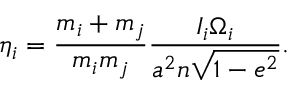Convert formula to latex. <formula><loc_0><loc_0><loc_500><loc_500>\eta _ { i } = \frac { m _ { i } + m _ { j } } { m _ { i } m _ { j } } \frac { I _ { i } \Omega _ { i } } { a ^ { 2 } n \sqrt { 1 - e ^ { 2 } } } .</formula> 